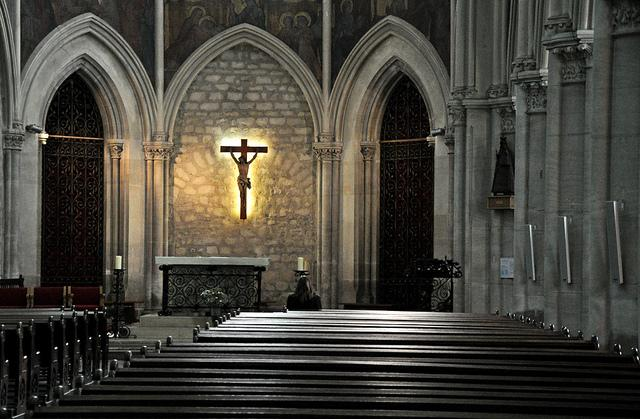How might you be considered if you set a fire here?

Choices:
A) sacrilegious
B) forest-fire starter
C) chef
D) camper sacrilegious 